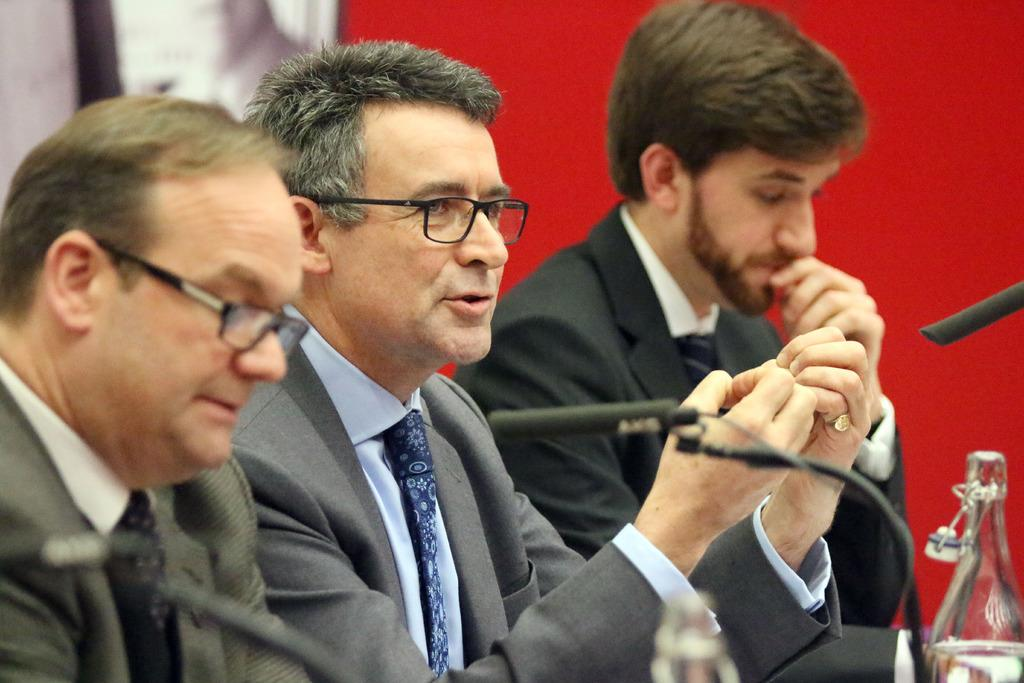What are the people in the image doing? The people in the image are sitting. What objects are present in the image that might be used for amplifying sound? There are microphones in the image. What type of containers can be seen in the image? There are bottles in the image. What color is the background of the image? The background of the image is red. How many bears are visible in the image? There are no bears present in the image. What type of unit is being measured by the people in the image? There is no indication of any unit being measured in the image. 